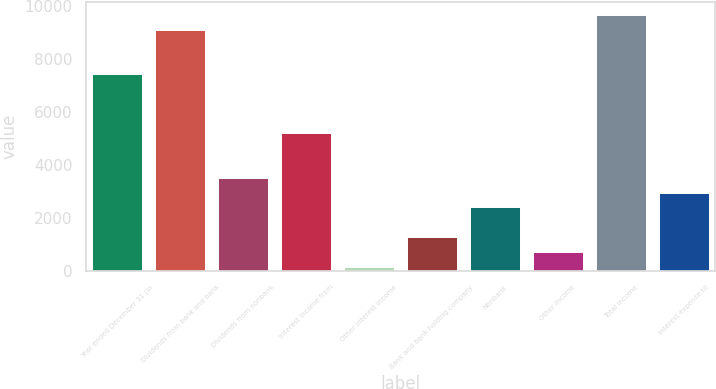Convert chart. <chart><loc_0><loc_0><loc_500><loc_500><bar_chart><fcel>Year ended December 31 (in<fcel>Dividends from bank and bank<fcel>Dividends from nonbank<fcel>Interest income from<fcel>Other interest income<fcel>Bank and bank holding company<fcel>Nonbank<fcel>Other income<fcel>Total income<fcel>Interest expense to<nl><fcel>7435.8<fcel>9117.6<fcel>3511.6<fcel>5193.4<fcel>148<fcel>1269.2<fcel>2390.4<fcel>708.6<fcel>9678.2<fcel>2951<nl></chart> 